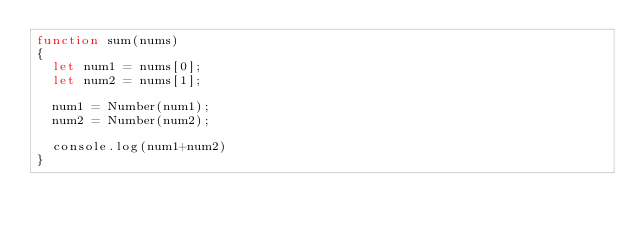<code> <loc_0><loc_0><loc_500><loc_500><_JavaScript_>function sum(nums)
{
  let num1 = nums[0];
  let num2 = nums[1];

  num1 = Number(num1);
  num2 = Number(num2);

  console.log(num1+num2)
}
</code> 